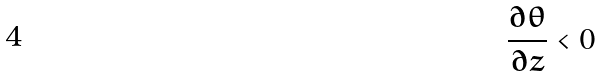Convert formula to latex. <formula><loc_0><loc_0><loc_500><loc_500>\frac { \partial \theta } { \partial z } < 0</formula> 